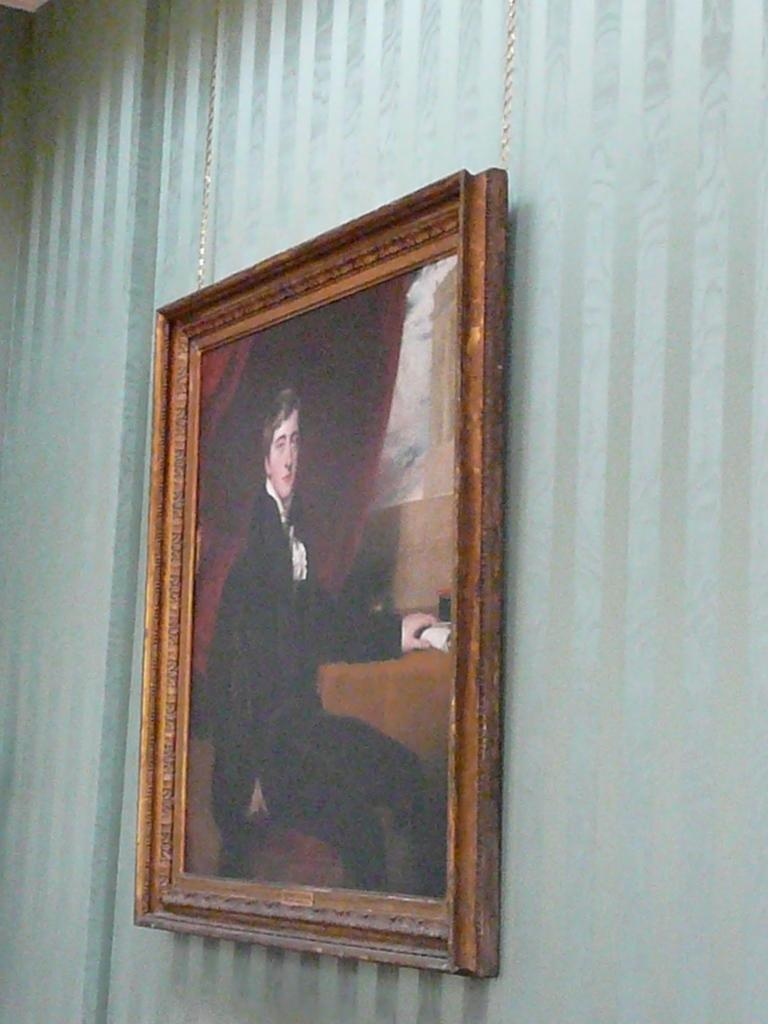What object is in the center of the image? There is a photo frame in the center of the image. Where is the photo frame located? The photo frame is on the wall. Can you describe the position of the photo frame in relation to the image? The photo frame is in the center of the image. What need does the photo frame fulfill in the image? The photo frame does not fulfill a need in the image, as it is an inanimate object. 